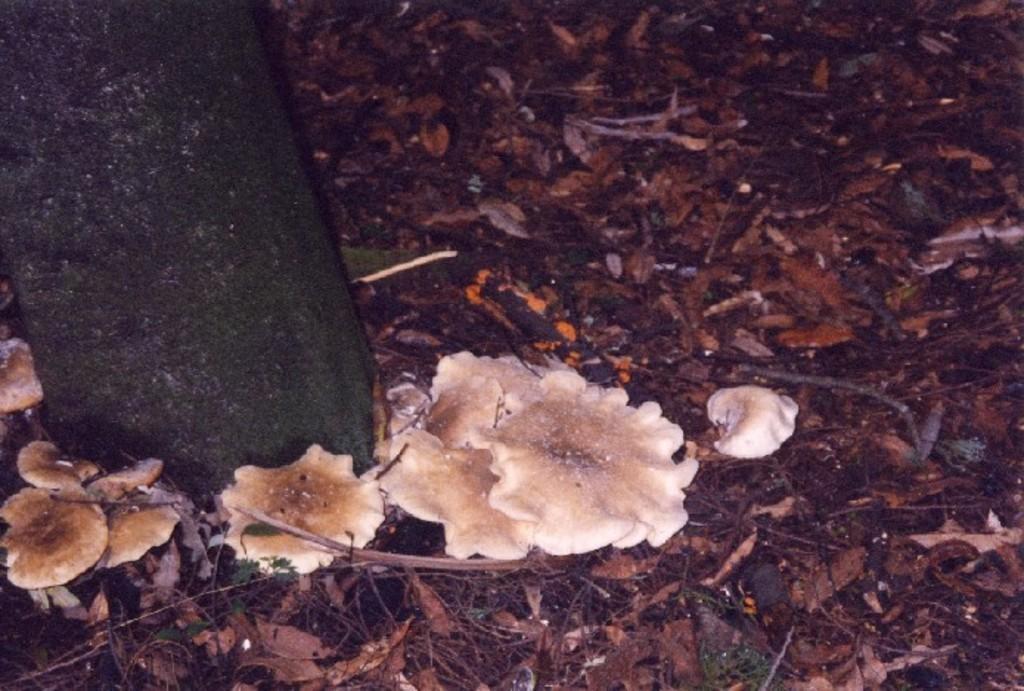Please provide a concise description of this image. In the image we can see dry grass, mushrooms and tree trunk. 